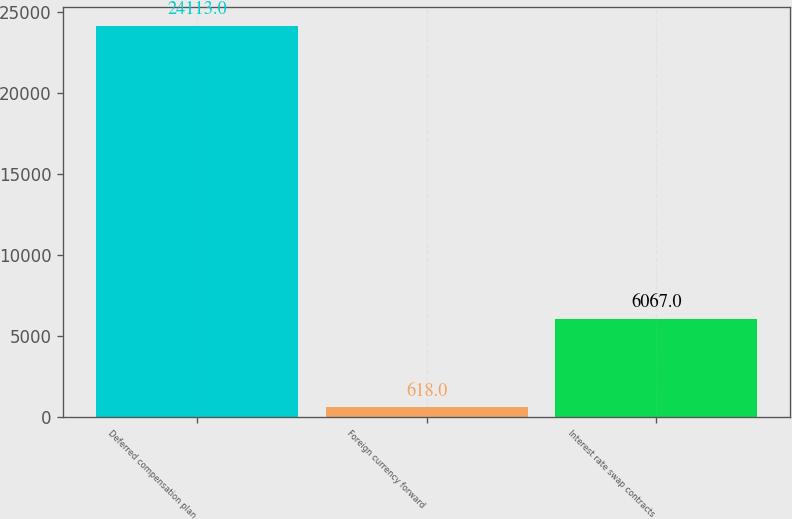<chart> <loc_0><loc_0><loc_500><loc_500><bar_chart><fcel>Deferred compensation plan<fcel>Foreign currency forward<fcel>Interest rate swap contracts<nl><fcel>24113<fcel>618<fcel>6067<nl></chart> 